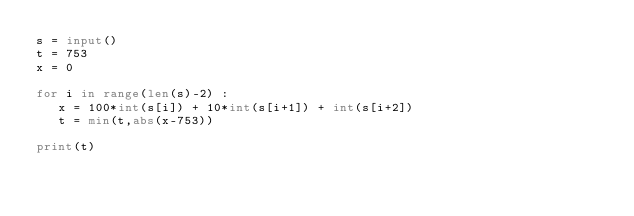<code> <loc_0><loc_0><loc_500><loc_500><_Python_>s = input()
t = 753
x = 0

for i in range(len(s)-2) :
   x = 100*int(s[i]) + 10*int(s[i+1]) + int(s[i+2])
   t = min(t,abs(x-753))

print(t)</code> 